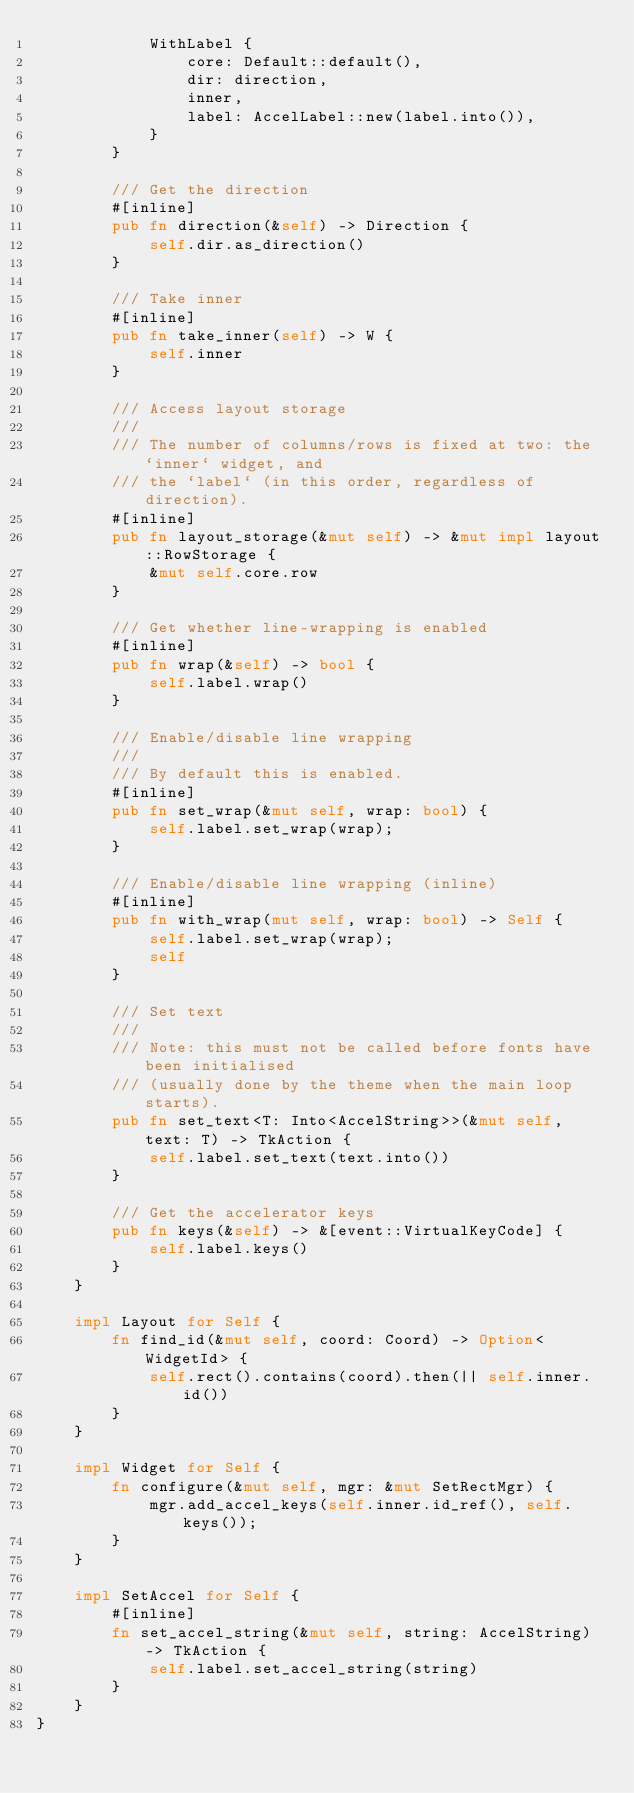<code> <loc_0><loc_0><loc_500><loc_500><_Rust_>            WithLabel {
                core: Default::default(),
                dir: direction,
                inner,
                label: AccelLabel::new(label.into()),
            }
        }

        /// Get the direction
        #[inline]
        pub fn direction(&self) -> Direction {
            self.dir.as_direction()
        }

        /// Take inner
        #[inline]
        pub fn take_inner(self) -> W {
            self.inner
        }

        /// Access layout storage
        ///
        /// The number of columns/rows is fixed at two: the `inner` widget, and
        /// the `label` (in this order, regardless of direction).
        #[inline]
        pub fn layout_storage(&mut self) -> &mut impl layout::RowStorage {
            &mut self.core.row
        }

        /// Get whether line-wrapping is enabled
        #[inline]
        pub fn wrap(&self) -> bool {
            self.label.wrap()
        }

        /// Enable/disable line wrapping
        ///
        /// By default this is enabled.
        #[inline]
        pub fn set_wrap(&mut self, wrap: bool) {
            self.label.set_wrap(wrap);
        }

        /// Enable/disable line wrapping (inline)
        #[inline]
        pub fn with_wrap(mut self, wrap: bool) -> Self {
            self.label.set_wrap(wrap);
            self
        }

        /// Set text
        ///
        /// Note: this must not be called before fonts have been initialised
        /// (usually done by the theme when the main loop starts).
        pub fn set_text<T: Into<AccelString>>(&mut self, text: T) -> TkAction {
            self.label.set_text(text.into())
        }

        /// Get the accelerator keys
        pub fn keys(&self) -> &[event::VirtualKeyCode] {
            self.label.keys()
        }
    }

    impl Layout for Self {
        fn find_id(&mut self, coord: Coord) -> Option<WidgetId> {
            self.rect().contains(coord).then(|| self.inner.id())
        }
    }

    impl Widget for Self {
        fn configure(&mut self, mgr: &mut SetRectMgr) {
            mgr.add_accel_keys(self.inner.id_ref(), self.keys());
        }
    }

    impl SetAccel for Self {
        #[inline]
        fn set_accel_string(&mut self, string: AccelString) -> TkAction {
            self.label.set_accel_string(string)
        }
    }
}
</code> 